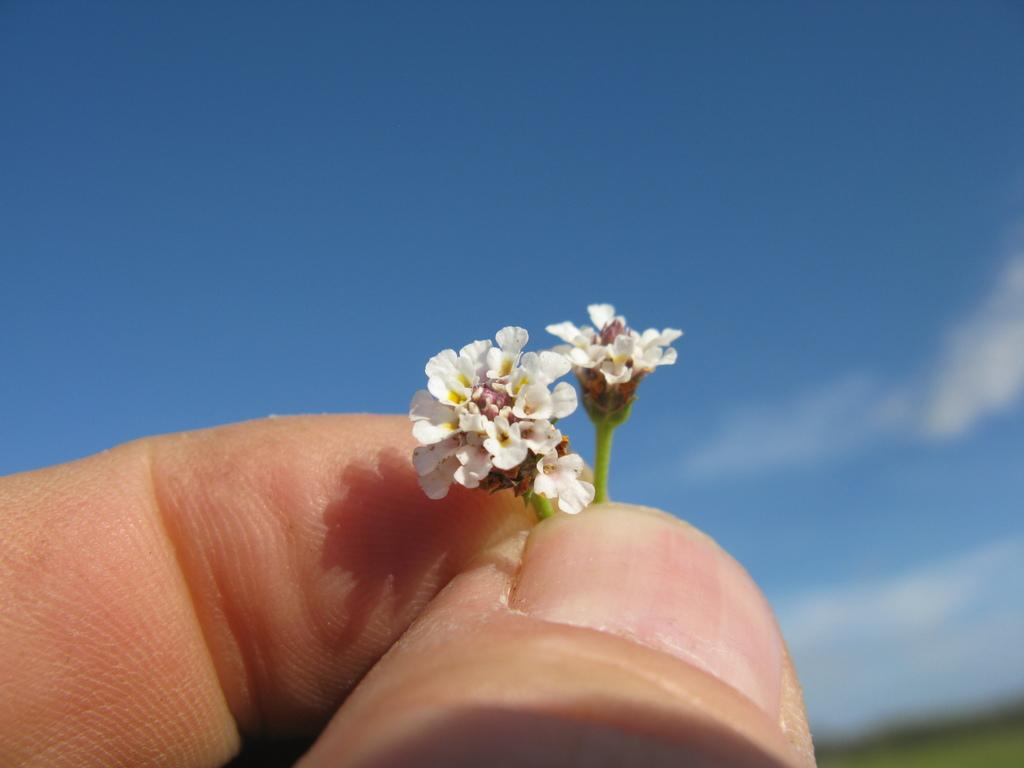Who or what is the main subject in the image? There is a person in the image. What is the person holding in the image? The person is holding two tiny flowers. How are the flowers being held by the person? The flowers are held by the person's fingers. What can be seen in the background of the image? There is a sky visible in the background of the image. What type of truck can be seen driving on the top of the person's head in the image? There is no truck visible in the image, nor is there any indication of a truck driving on the person's head. 